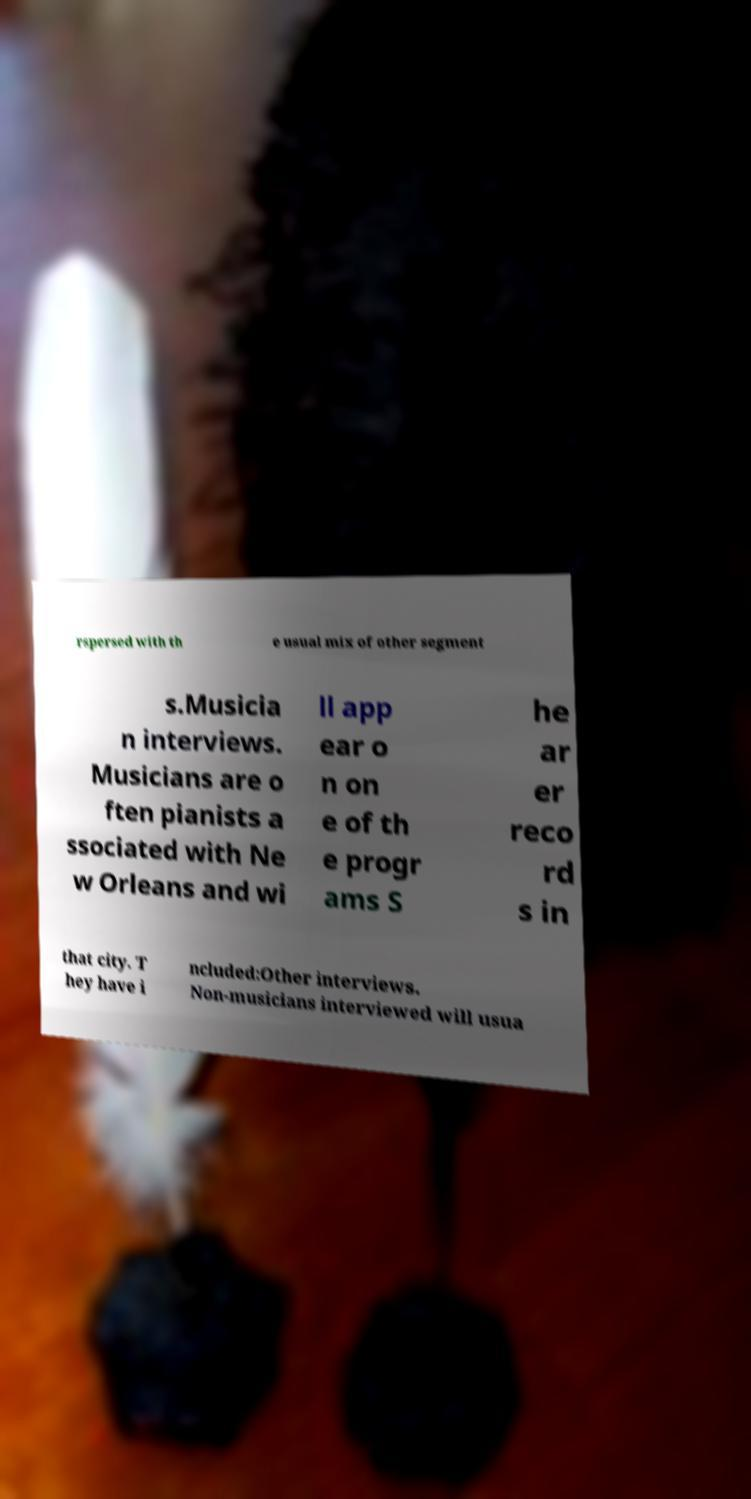Can you accurately transcribe the text from the provided image for me? rspersed with th e usual mix of other segment s.Musicia n interviews. Musicians are o ften pianists a ssociated with Ne w Orleans and wi ll app ear o n on e of th e progr ams S he ar er reco rd s in that city. T hey have i ncluded:Other interviews. Non-musicians interviewed will usua 